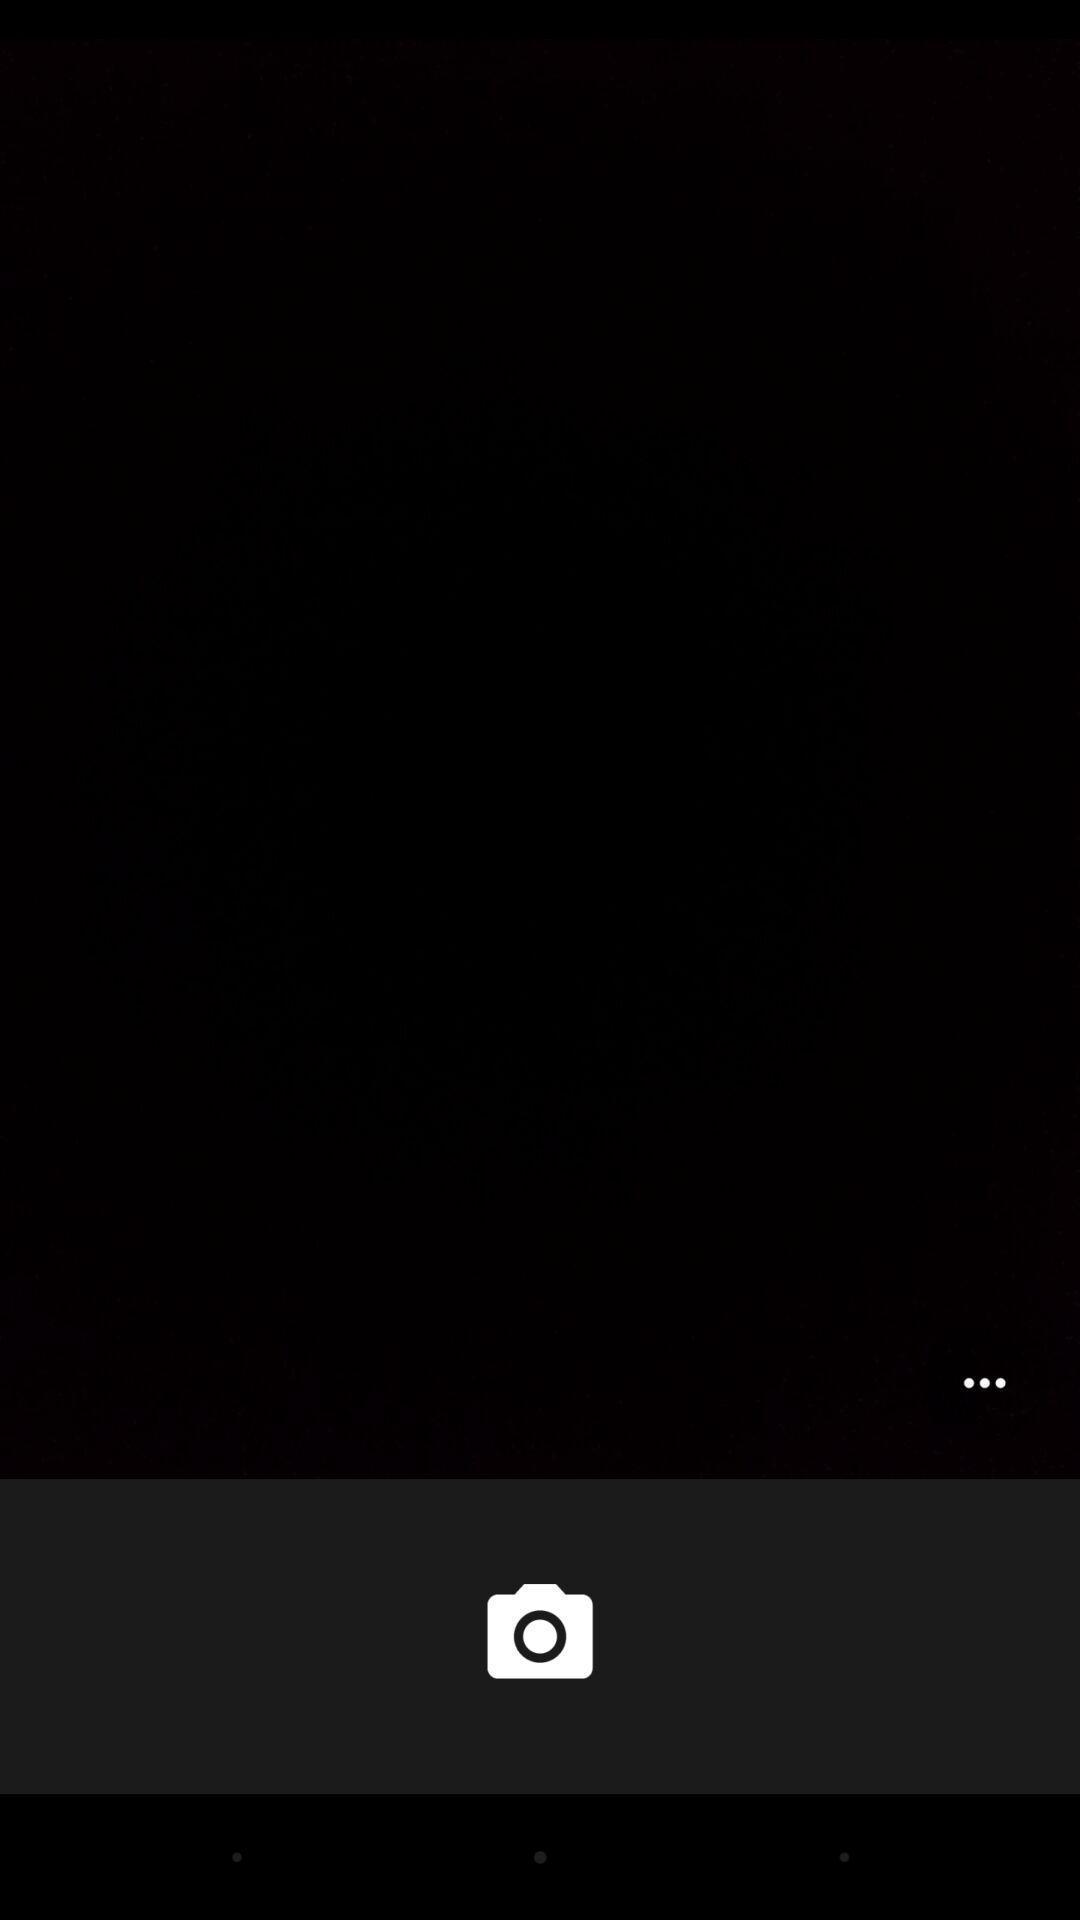Describe this image in words. Screen displaying a blank page with camera icon. 